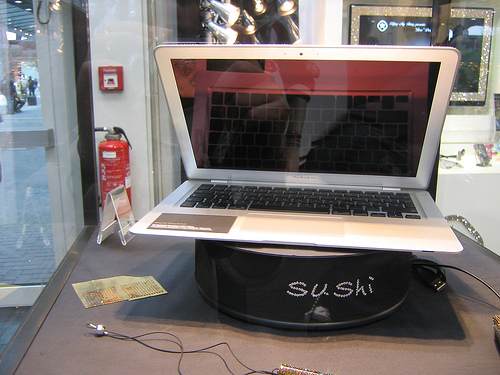<image>
Is there a column behind the laptop? Yes. From this viewpoint, the column is positioned behind the laptop, with the laptop partially or fully occluding the column. 